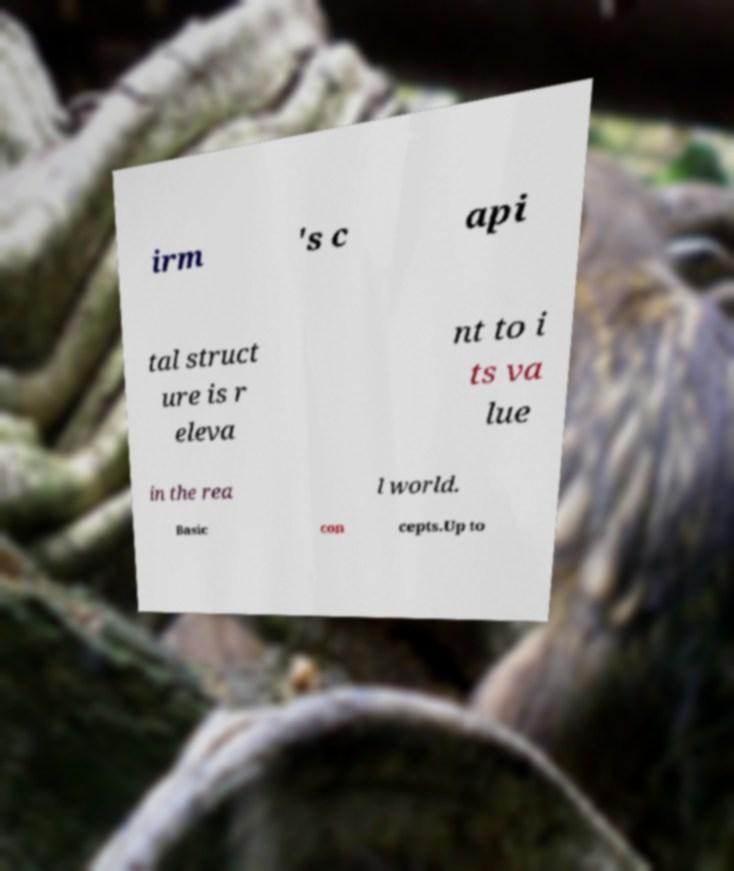Can you read and provide the text displayed in the image?This photo seems to have some interesting text. Can you extract and type it out for me? irm 's c api tal struct ure is r eleva nt to i ts va lue in the rea l world. Basic con cepts.Up to 